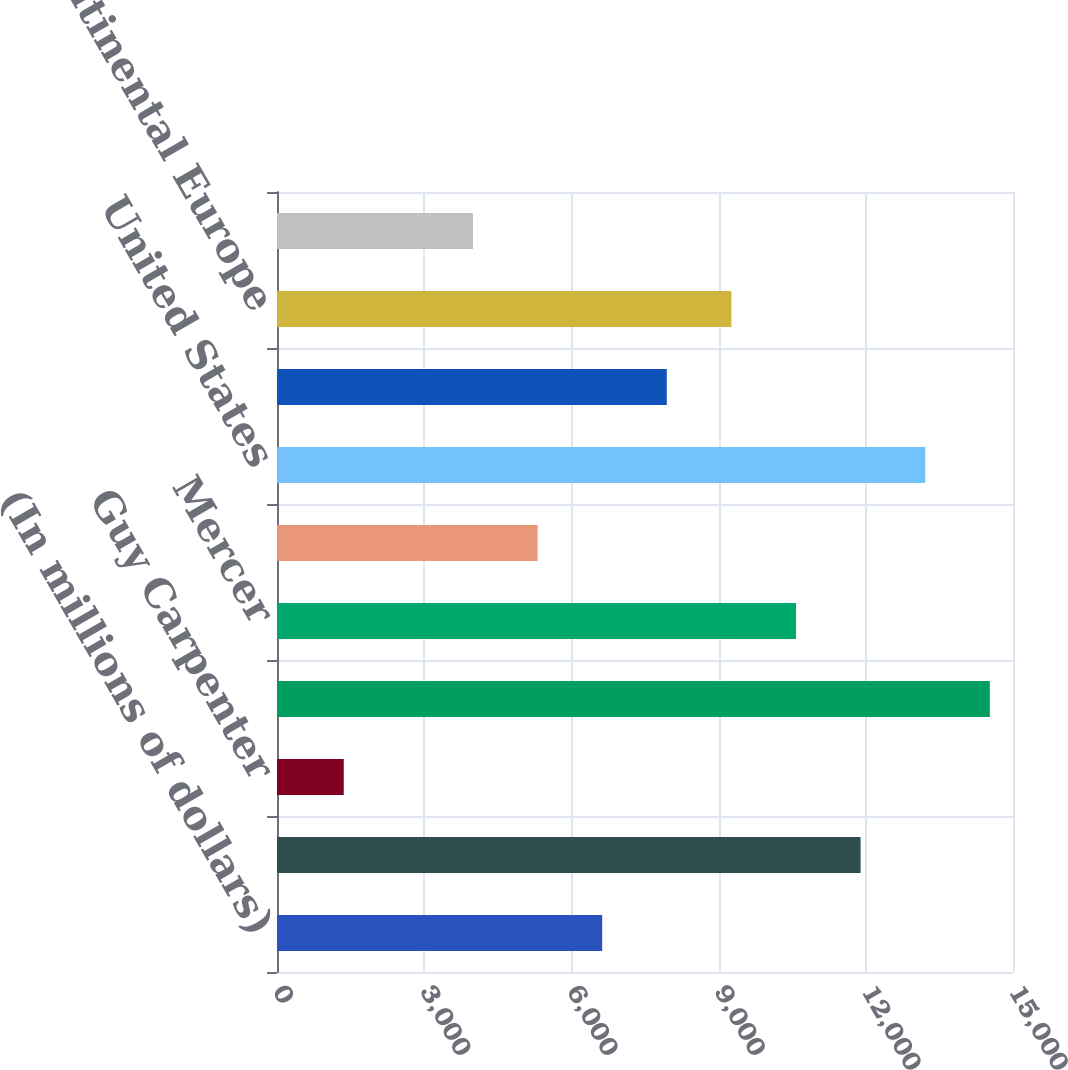Convert chart to OTSL. <chart><loc_0><loc_0><loc_500><loc_500><bar_chart><fcel>(In millions of dollars)<fcel>Marsh<fcel>Guy Carpenter<fcel>Total Risk and Insurance<fcel>Mercer<fcel>Oliver Wyman Group<fcel>United States<fcel>United Kingdom<fcel>Continental Europe<fcel>Asia Pacific<nl><fcel>6627.5<fcel>11894.3<fcel>1360.7<fcel>14527.7<fcel>10577.6<fcel>5310.8<fcel>13211<fcel>7944.2<fcel>9260.9<fcel>3994.1<nl></chart> 